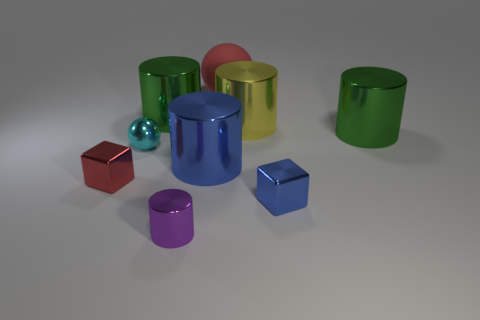Is there anything else that has the same material as the tiny cylinder?
Keep it short and to the point. Yes. Are the big red ball and the small object that is behind the red shiny cube made of the same material?
Your response must be concise. No. Are there fewer cyan shiny spheres on the right side of the matte object than things that are in front of the cyan object?
Your answer should be compact. Yes. What material is the big green cylinder in front of the yellow cylinder?
Provide a succinct answer. Metal. There is a metallic object that is both in front of the red metallic object and to the right of the large blue thing; what color is it?
Give a very brief answer. Blue. What number of other things are the same color as the small cylinder?
Provide a succinct answer. 0. The large metal cylinder that is to the right of the big yellow shiny cylinder is what color?
Offer a very short reply. Green. Is there a object that has the same size as the red block?
Provide a short and direct response. Yes. There is a sphere that is the same size as the red cube; what is it made of?
Provide a succinct answer. Metal. How many things are blue metallic objects that are behind the red cube or blocks to the right of the large red rubber sphere?
Your response must be concise. 2. 